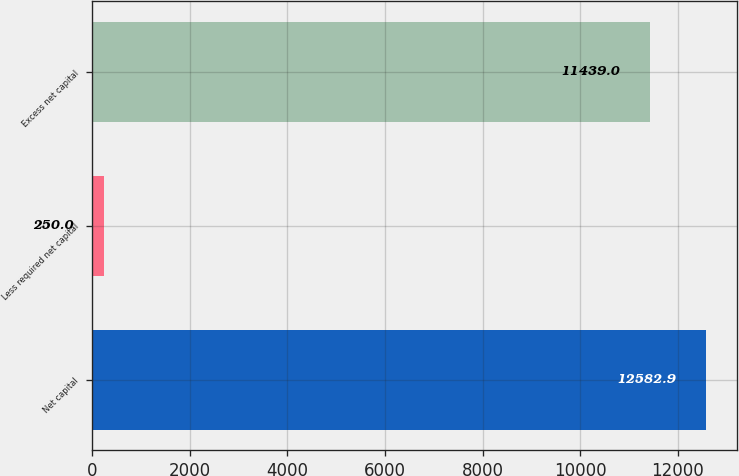<chart> <loc_0><loc_0><loc_500><loc_500><bar_chart><fcel>Net capital<fcel>Less required net capital<fcel>Excess net capital<nl><fcel>12582.9<fcel>250<fcel>11439<nl></chart> 